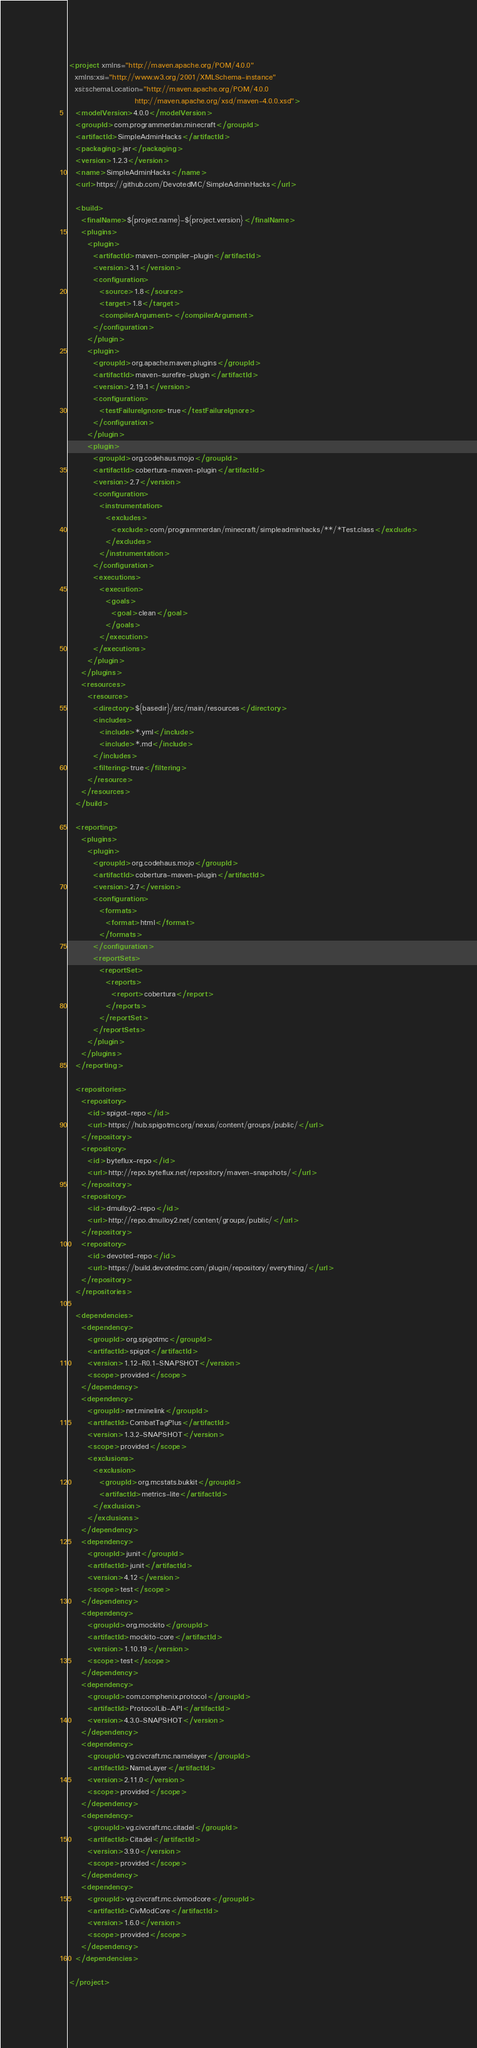Convert code to text. <code><loc_0><loc_0><loc_500><loc_500><_XML_><project xmlns="http://maven.apache.org/POM/4.0.0"
  xmlns:xsi="http://www.w3.org/2001/XMLSchema-instance"
  xsi:schemaLocation="http://maven.apache.org/POM/4.0.0
                      http://maven.apache.org/xsd/maven-4.0.0.xsd">
  <modelVersion>4.0.0</modelVersion>
  <groupId>com.programmerdan.minecraft</groupId>
  <artifactId>SimpleAdminHacks</artifactId>
  <packaging>jar</packaging>
  <version>1.2.3</version>
  <name>SimpleAdminHacks</name>
  <url>https://github.com/DevotedMC/SimpleAdminHacks</url>

  <build>
    <finalName>${project.name}-${project.version}</finalName>
    <plugins>
      <plugin>
        <artifactId>maven-compiler-plugin</artifactId>
        <version>3.1</version>
        <configuration>
          <source>1.8</source>
          <target>1.8</target>
          <compilerArgument></compilerArgument>
        </configuration>
      </plugin>
      <plugin>
        <groupId>org.apache.maven.plugins</groupId>
        <artifactId>maven-surefire-plugin</artifactId>
        <version>2.19.1</version>
        <configuration>
          <testFailureIgnore>true</testFailureIgnore>
        </configuration>
      </plugin>
      <plugin>
        <groupId>org.codehaus.mojo</groupId>
        <artifactId>cobertura-maven-plugin</artifactId>
        <version>2.7</version>
        <configuration>
          <instrumentation>
            <excludes>
              <exclude>com/programmerdan/minecraft/simpleadminhacks/**/*Test.class</exclude>
            </excludes>
          </instrumentation>
        </configuration>
        <executions>
          <execution>
            <goals>
              <goal>clean</goal>
            </goals>
          </execution>
        </executions>
      </plugin>
    </plugins>
    <resources>
      <resource>
        <directory>${basedir}/src/main/resources</directory>
        <includes>
          <include>*.yml</include>
          <include>*.md</include>
        </includes>
        <filtering>true</filtering>
      </resource>
    </resources>
  </build>

  <reporting>
    <plugins>
      <plugin>
        <groupId>org.codehaus.mojo</groupId>
        <artifactId>cobertura-maven-plugin</artifactId>
        <version>2.7</version>
        <configuration>
          <formats>
            <format>html</format>
          </formats>
        </configuration>
        <reportSets>
          <reportSet>
            <reports>
              <report>cobertura</report>
            </reports>
          </reportSet>
        </reportSets>
      </plugin>
    </plugins>
  </reporting>

  <repositories>
    <repository>
      <id>spigot-repo</id>
      <url>https://hub.spigotmc.org/nexus/content/groups/public/</url>
    </repository>
    <repository>
      <id>byteflux-repo</id>
      <url>http://repo.byteflux.net/repository/maven-snapshots/</url>
    </repository>
    <repository>
      <id>dmulloy2-repo</id>
      <url>http://repo.dmulloy2.net/content/groups/public/</url>
    </repository>
    <repository>
      <id>devoted-repo</id>
      <url>https://build.devotedmc.com/plugin/repository/everything/</url>
    </repository>
  </repositories>

  <dependencies>
    <dependency>
      <groupId>org.spigotmc</groupId>
      <artifactId>spigot</artifactId>
      <version>1.12-R0.1-SNAPSHOT</version>
      <scope>provided</scope>
    </dependency>
    <dependency>
      <groupId>net.minelink</groupId>
      <artifactId>CombatTagPlus</artifactId>
      <version>1.3.2-SNAPSHOT</version>
      <scope>provided</scope>
      <exclusions>
        <exclusion>
          <groupId>org.mcstats.bukkit</groupId>
          <artifactId>metrics-lite</artifactId>
        </exclusion>
      </exclusions>
    </dependency>
    <dependency>
      <groupId>junit</groupId>
      <artifactId>junit</artifactId>
      <version>4.12</version>
      <scope>test</scope>
    </dependency>
    <dependency>
      <groupId>org.mockito</groupId>
      <artifactId>mockito-core</artifactId>
      <version>1.10.19</version>
      <scope>test</scope>
    </dependency>
    <dependency>
      <groupId>com.comphenix.protocol</groupId>
      <artifactId>ProtocolLib-API</artifactId>
      <version>4.3.0-SNAPSHOT</version>
    </dependency>
    <dependency>
      <groupId>vg.civcraft.mc.namelayer</groupId>
      <artifactId>NameLayer</artifactId>
      <version>2.11.0</version>
      <scope>provided</scope>
    </dependency>
    <dependency>
      <groupId>vg.civcraft.mc.citadel</groupId>
      <artifactId>Citadel</artifactId>
      <version>3.9.0</version>
      <scope>provided</scope>
    </dependency>
    <dependency>
      <groupId>vg.civcraft.mc.civmodcore</groupId>
      <artifactId>CivModCore</artifactId>
      <version>1.6.0</version>
      <scope>provided</scope>
    </dependency>
  </dependencies>

</project>
</code> 